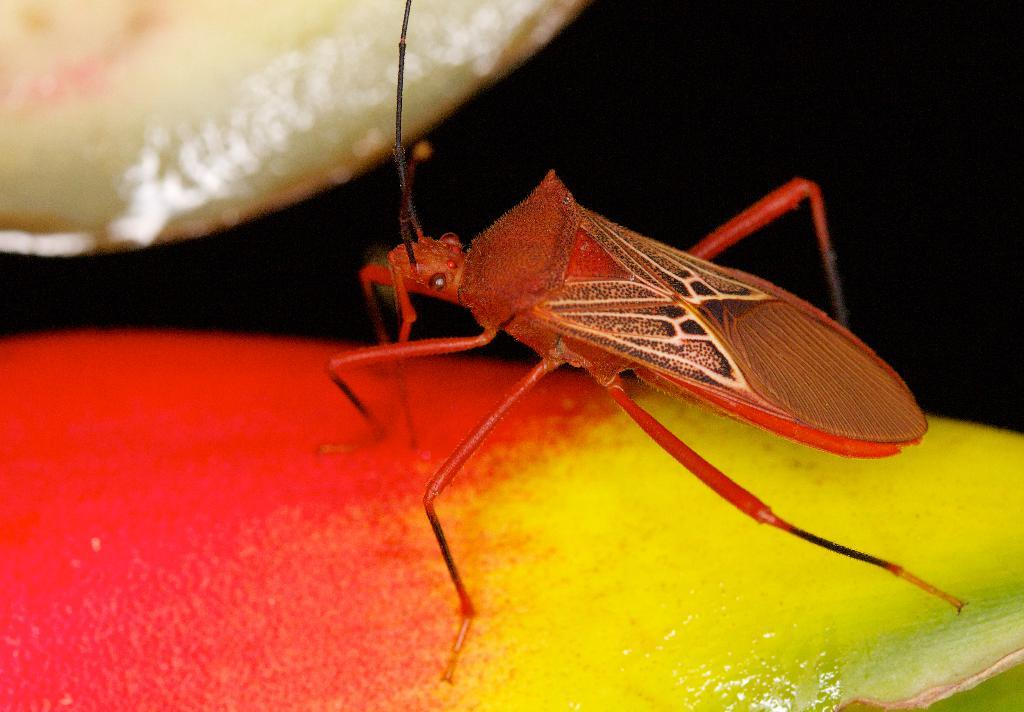What type of creature can be seen on an object in the image? There is an insect on an object in the image. What historical event is depicted in the image involving giants? There is no historical event or giants depicted in the image; it features an insect on an object. 